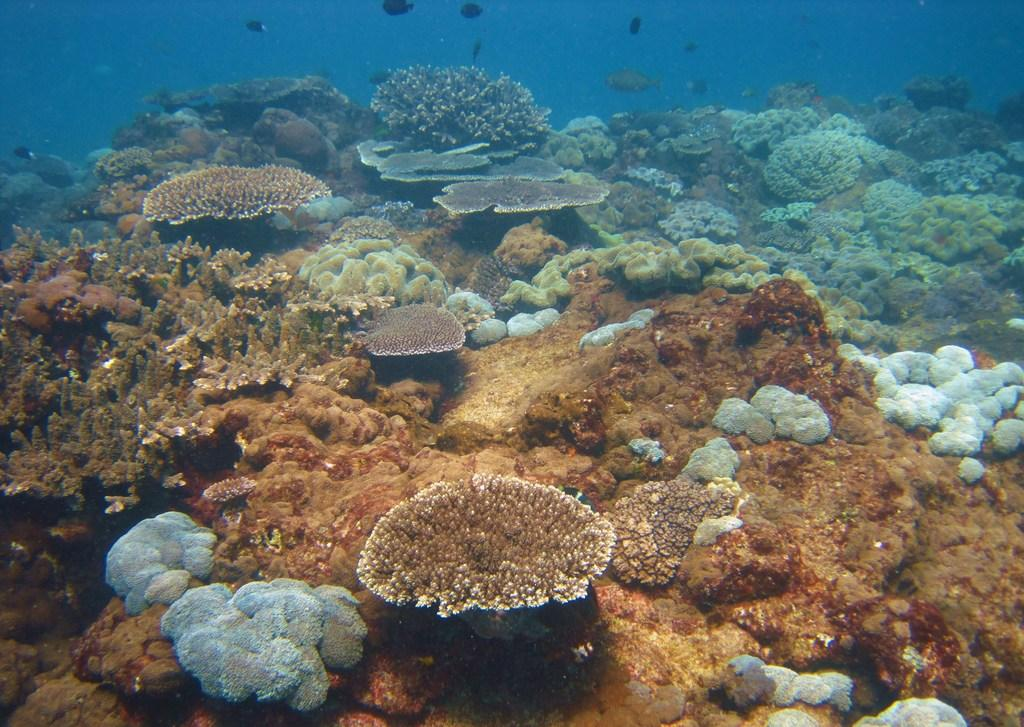What type of animals can be seen in the image? There are fishes in the image. What type of underwater environment is depicted in the image? There is a reef and coral in the image. In which medium are the fishes, reef, and coral located? The elements mentioned are in the water. What type of flowers can be seen growing on the coral in the image? There are no flowers present in the image; it features fishes, a reef, and coral in the water. 